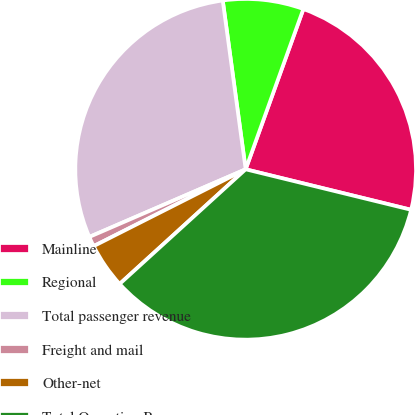<chart> <loc_0><loc_0><loc_500><loc_500><pie_chart><fcel>Mainline<fcel>Regional<fcel>Total passenger revenue<fcel>Freight and mail<fcel>Other-net<fcel>Total Operating Revenues<nl><fcel>23.32%<fcel>7.65%<fcel>29.35%<fcel>0.95%<fcel>4.3%<fcel>34.43%<nl></chart> 